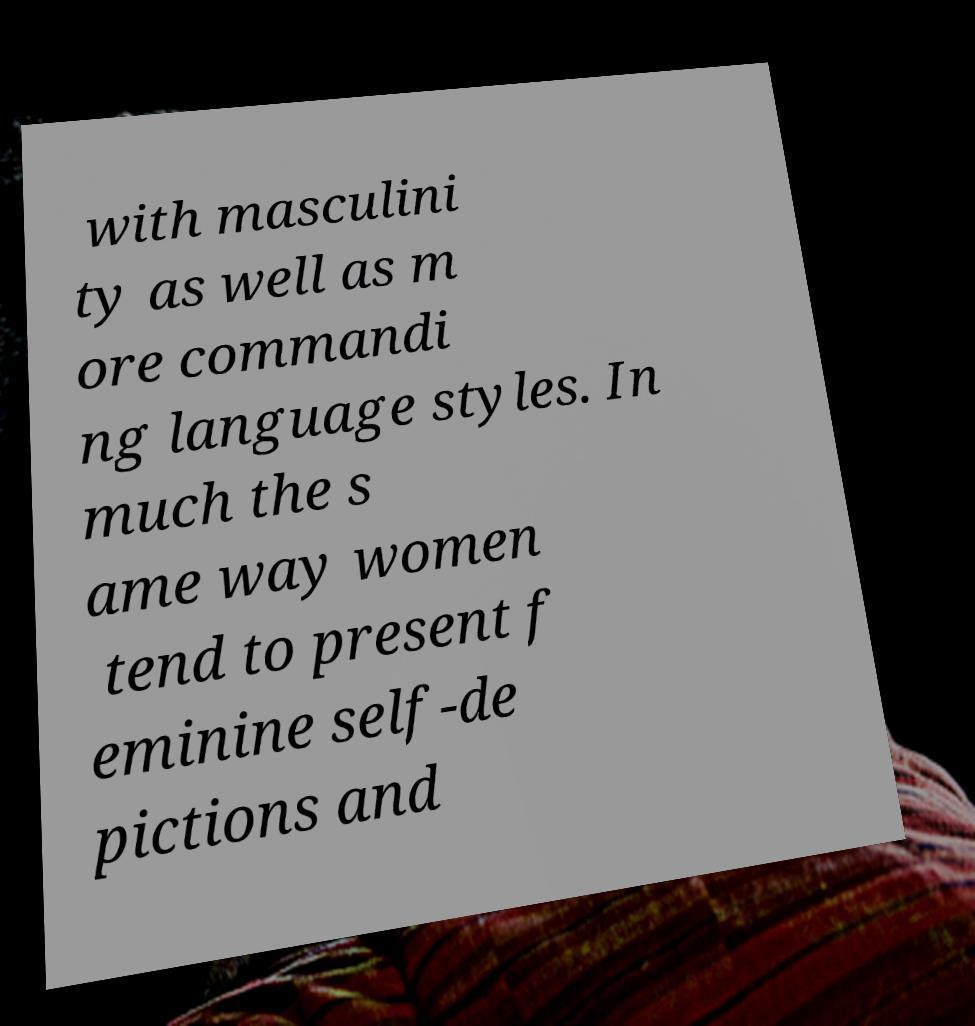Please read and relay the text visible in this image. What does it say? with masculini ty as well as m ore commandi ng language styles. In much the s ame way women tend to present f eminine self-de pictions and 